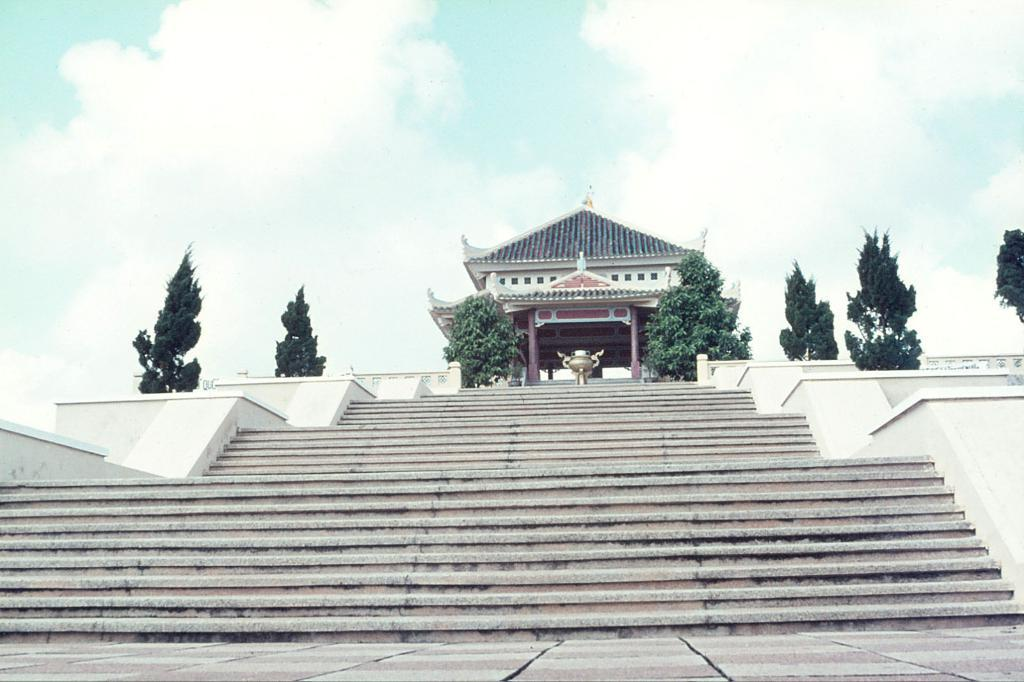What type of building is in the image? There is a temple in the image. What is located in front of the temple? There are steps in front of the temple. What can be seen on the other side of the steps? There are trees on the other side of the steps. What type of stocking is hanging from the temple in the image? There is no stocking present in the image. Can you hear a horn sounding in the image? There is no sound or horn present in the image. 